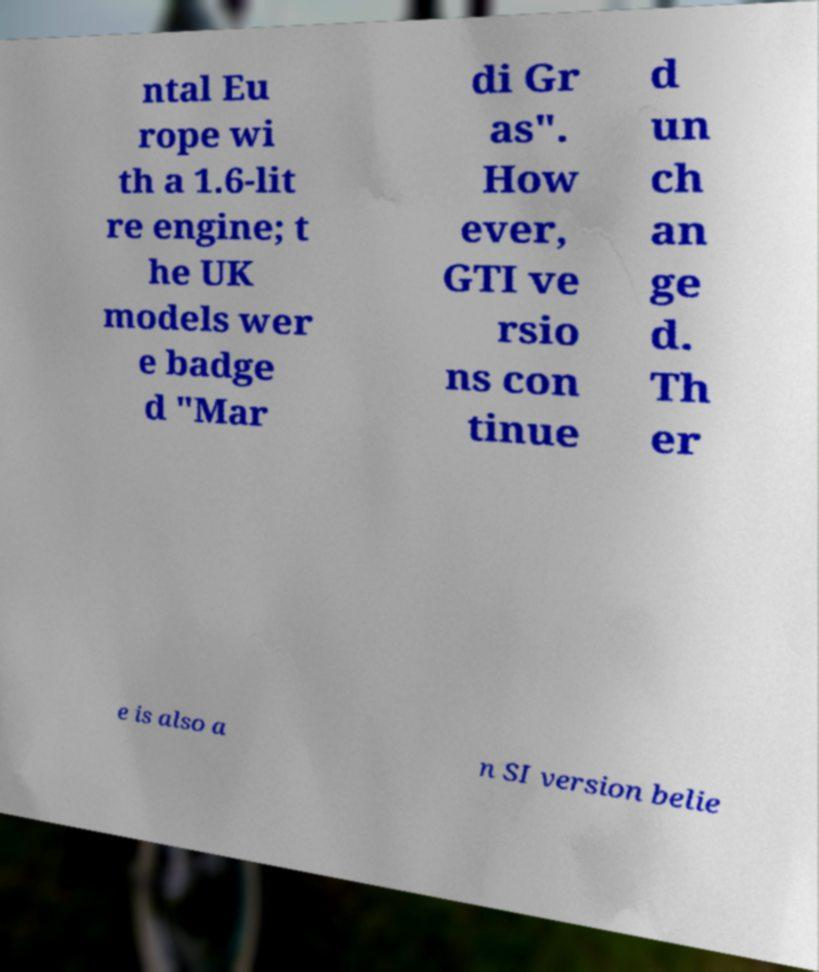Can you read and provide the text displayed in the image?This photo seems to have some interesting text. Can you extract and type it out for me? ntal Eu rope wi th a 1.6-lit re engine; t he UK models wer e badge d "Mar di Gr as". How ever, GTI ve rsio ns con tinue d un ch an ge d. Th er e is also a n SI version belie 